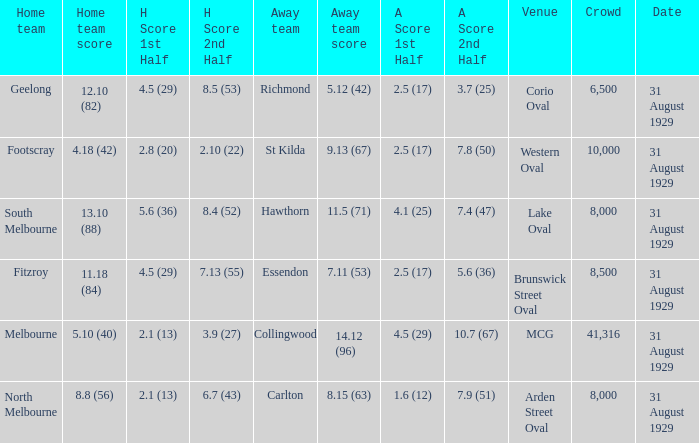What is the largest crowd when the away team is Hawthorn? 8000.0. 